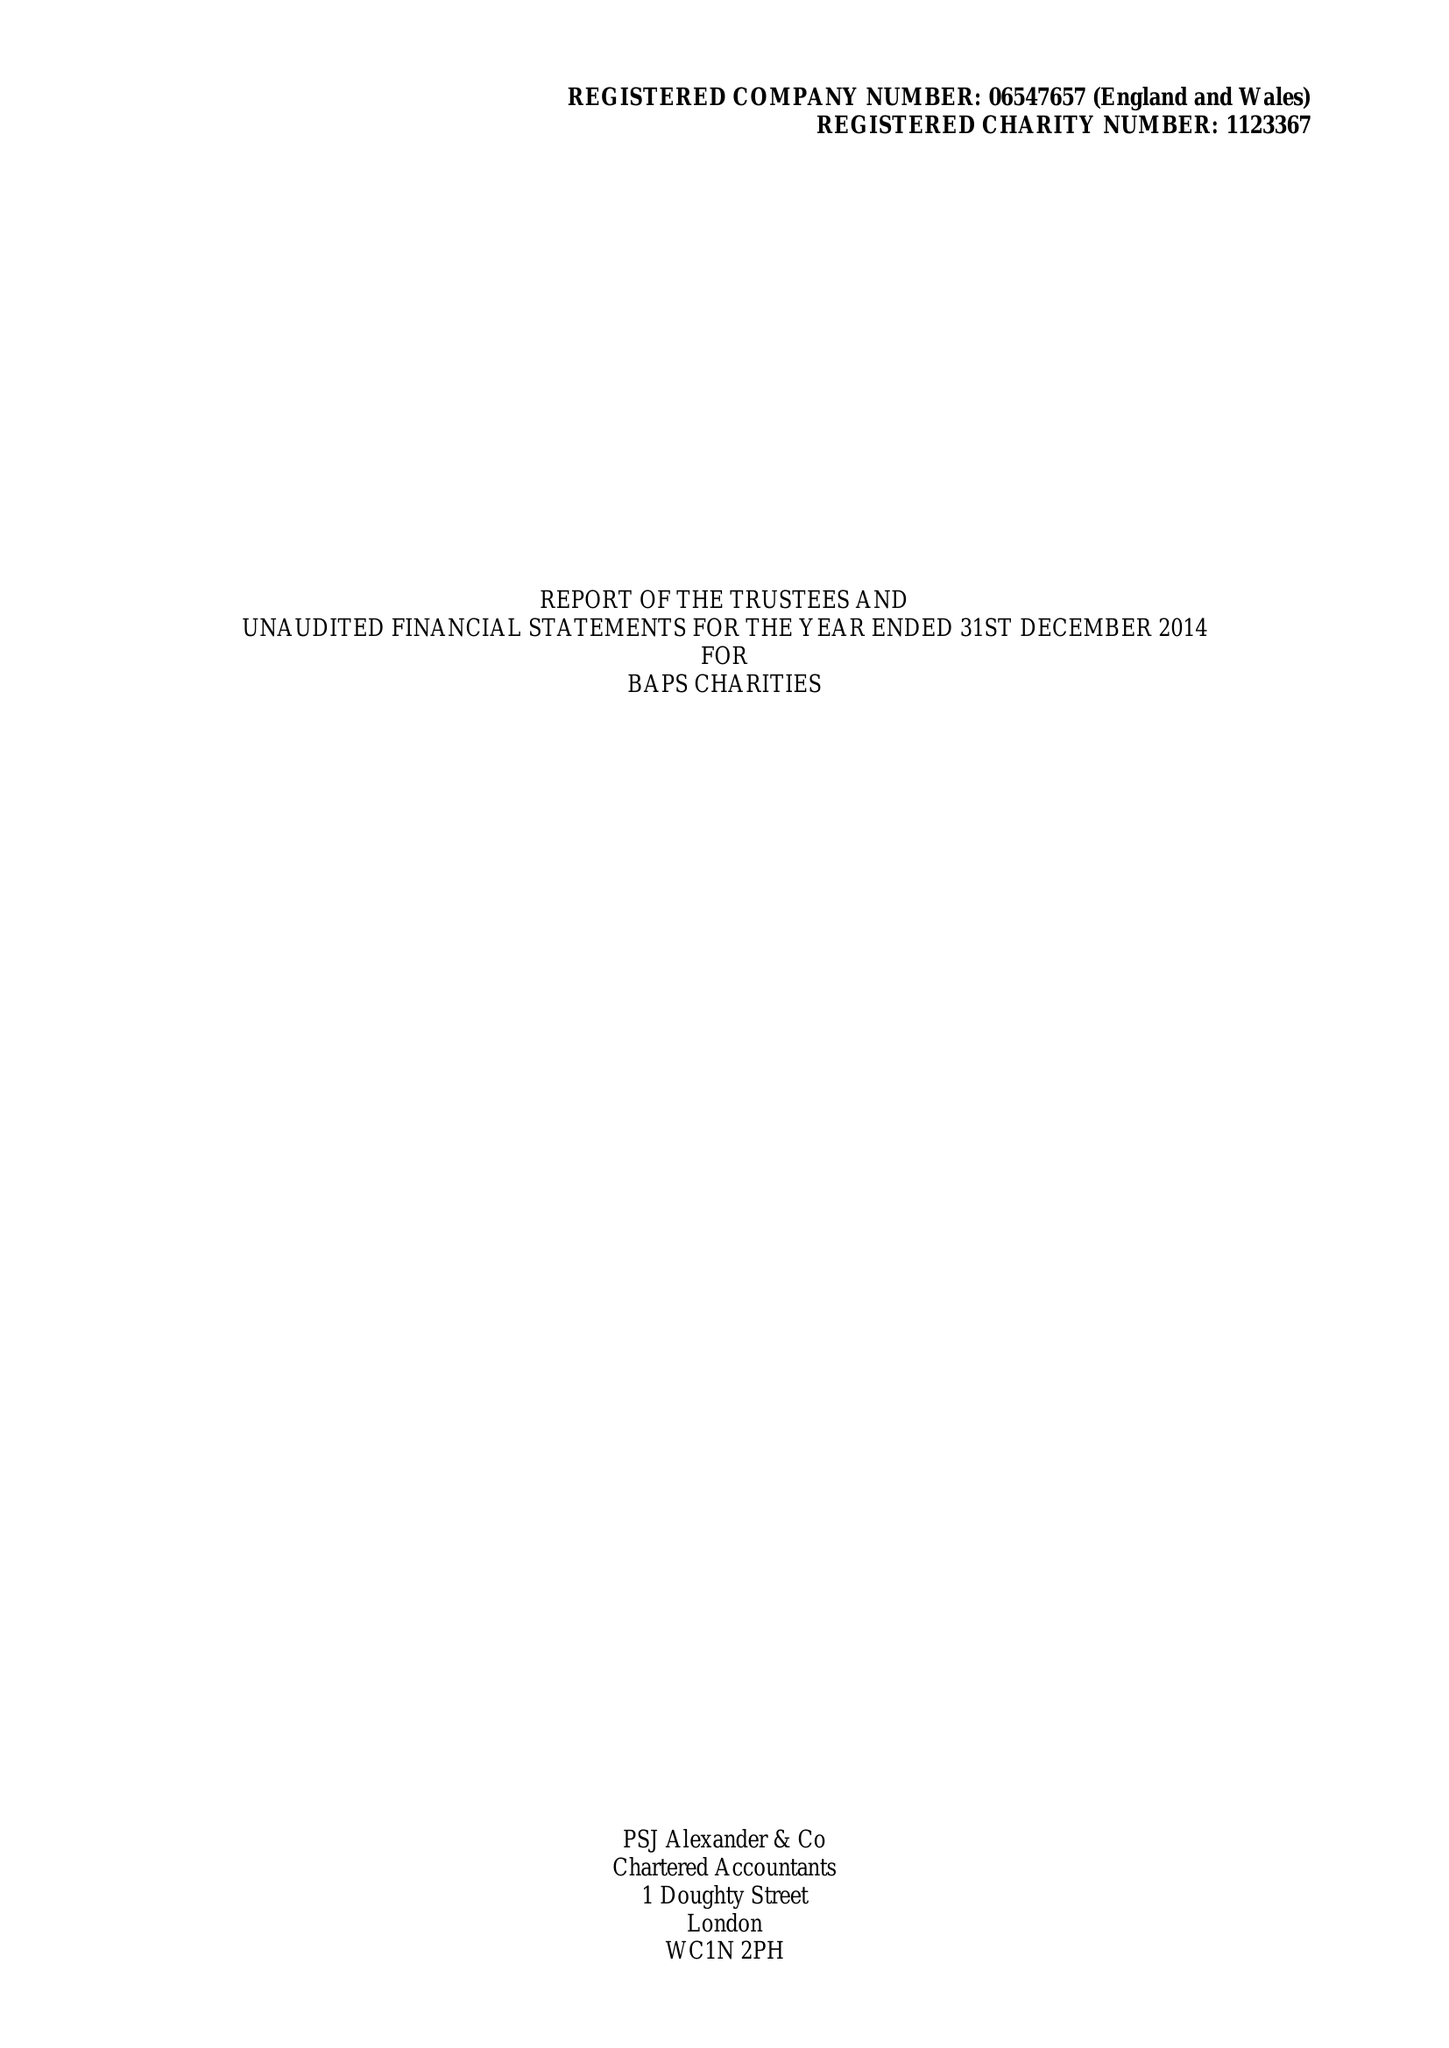What is the value for the address__street_line?
Answer the question using a single word or phrase. 54-62 MEADOW GARTH 